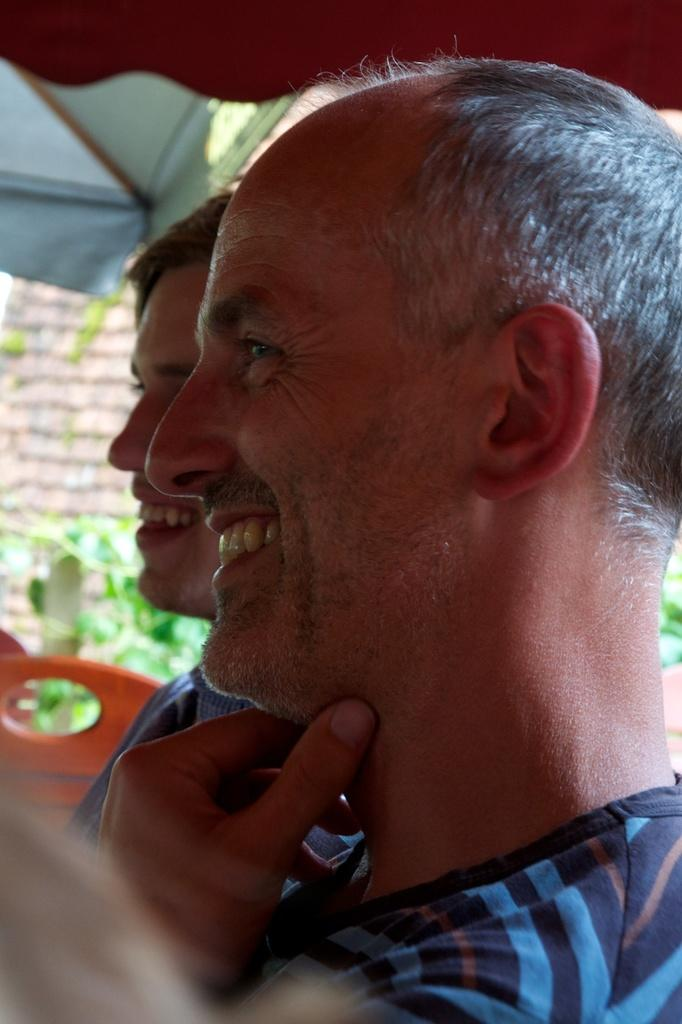How many people are in the image? There are two persons in the image. What are the persons wearing? The persons are wearing blue dress. What can be seen in the background of the image? There is a small plant and tents visible in the background. What type of rabbit can be seen singing songs in the image? There is no rabbit or singing in the image; it features two persons wearing blue dress and a background with a small plant and tents. 